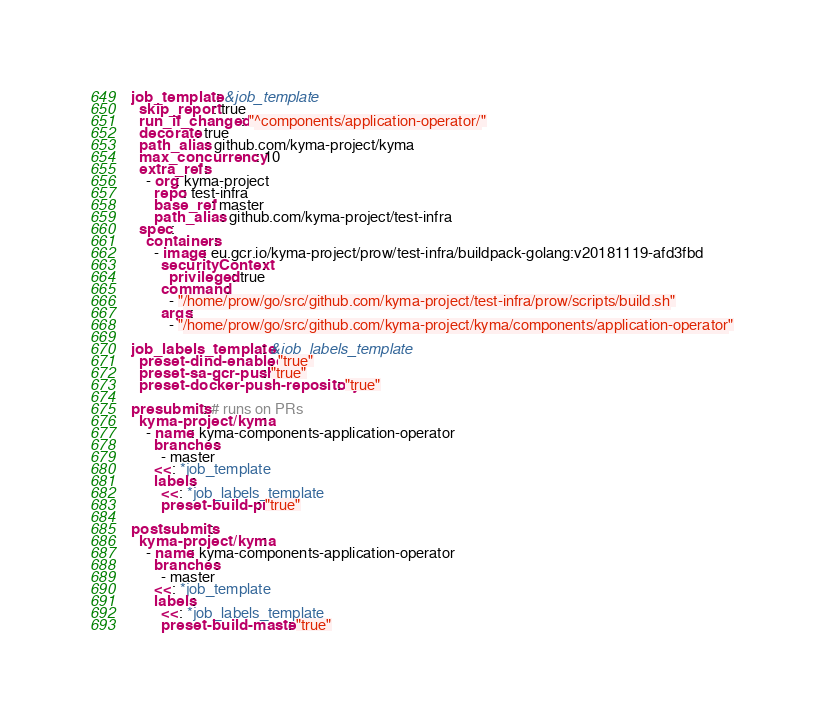Convert code to text. <code><loc_0><loc_0><loc_500><loc_500><_YAML_>job_template: &job_template
  skip_report: true
  run_if_changed: "^components/application-operator/"
  decorate: true
  path_alias: github.com/kyma-project/kyma
  max_concurrency: 10
  extra_refs:
    - org: kyma-project
      repo: test-infra
      base_ref: master
      path_alias: github.com/kyma-project/test-infra
  spec:
    containers:
      - image: eu.gcr.io/kyma-project/prow/test-infra/buildpack-golang:v20181119-afd3fbd
        securityContext:
          privileged: true
        command:
          - "/home/prow/go/src/github.com/kyma-project/test-infra/prow/scripts/build.sh"
        args:
          - "/home/prow/go/src/github.com/kyma-project/kyma/components/application-operator"

job_labels_template: &job_labels_template
  preset-dind-enabled: "true"
  preset-sa-gcr-push: "true"
  preset-docker-push-repository: "true"

presubmits: # runs on PRs
  kyma-project/kyma:
    - name: kyma-components-application-operator
      branches:
        - master
      <<: *job_template
      labels:
        <<: *job_labels_template
        preset-build-pr: "true"

postsubmits:
  kyma-project/kyma:
    - name: kyma-components-application-operator
      branches:
        - master
      <<: *job_template
      labels:
        <<: *job_labels_template
        preset-build-master: "true"
</code> 